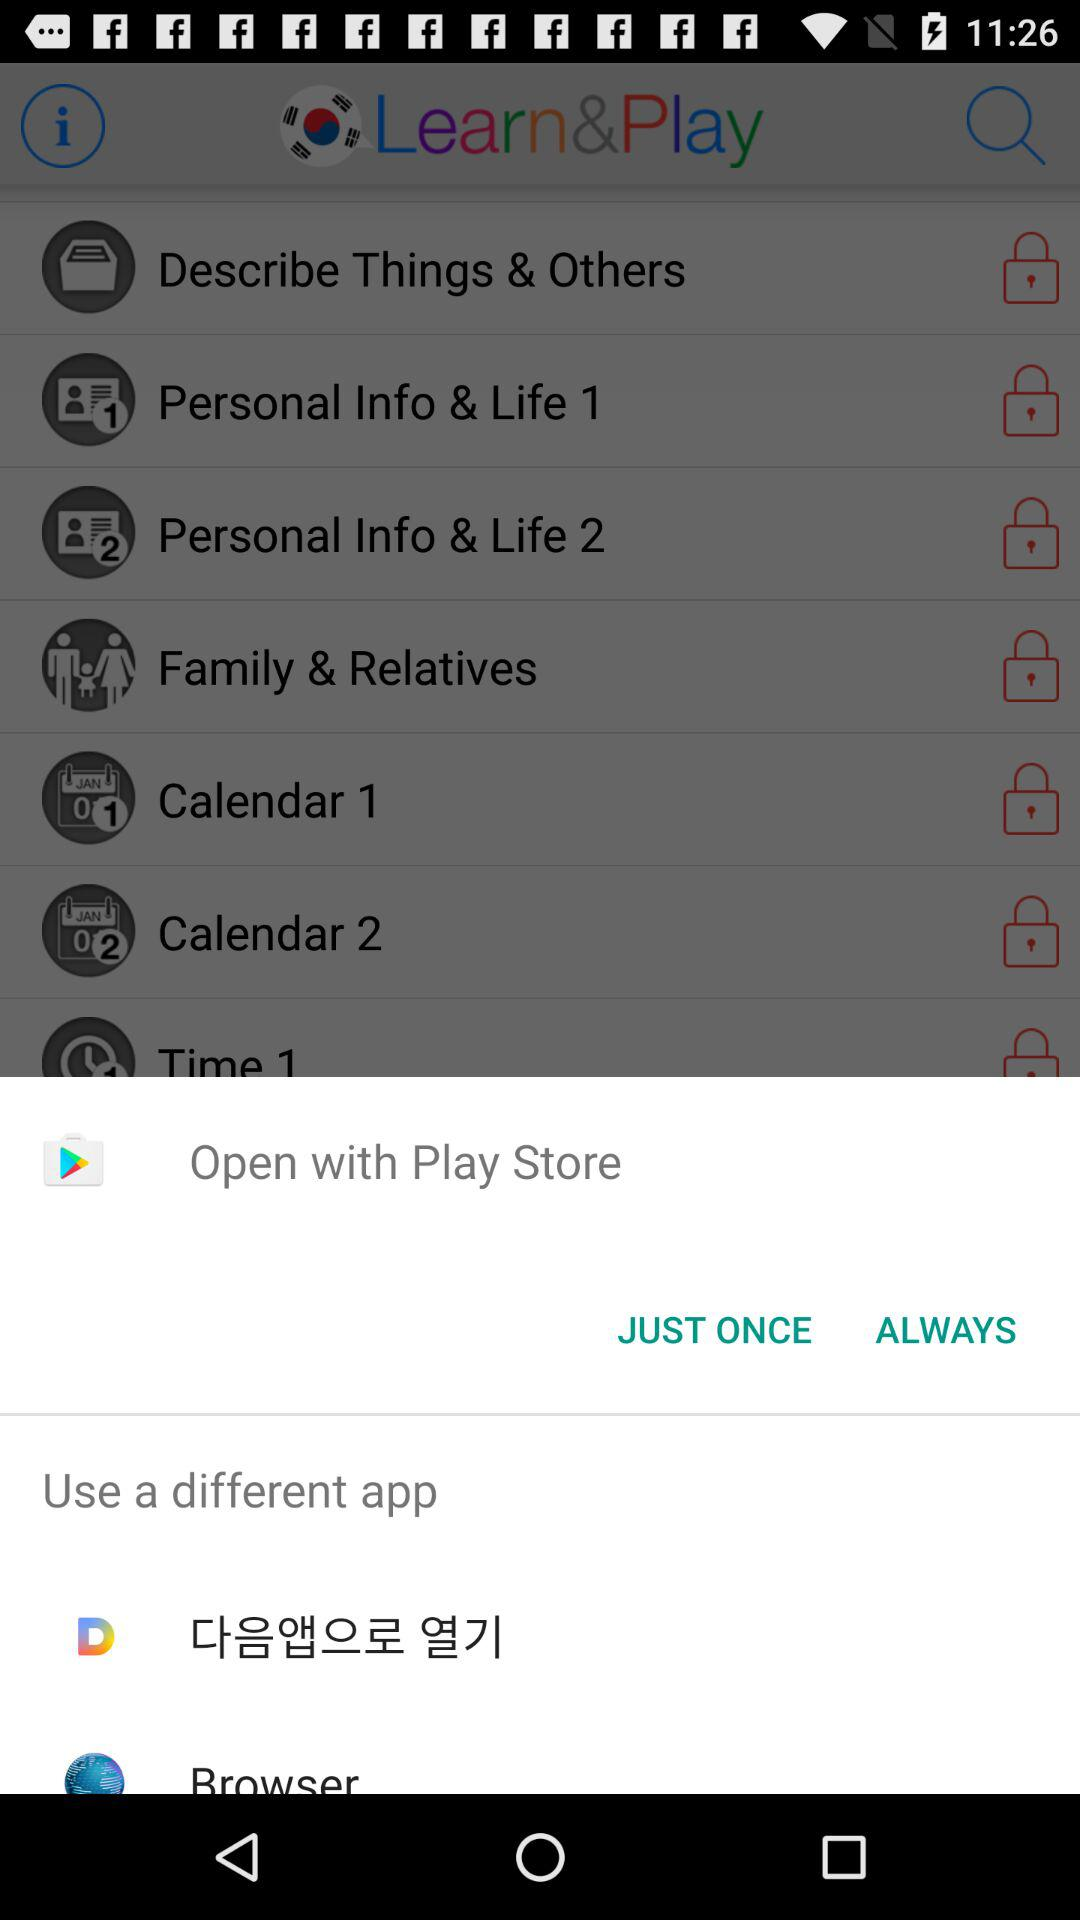What is the name of the application? The name of the application is "Learn&Play". 